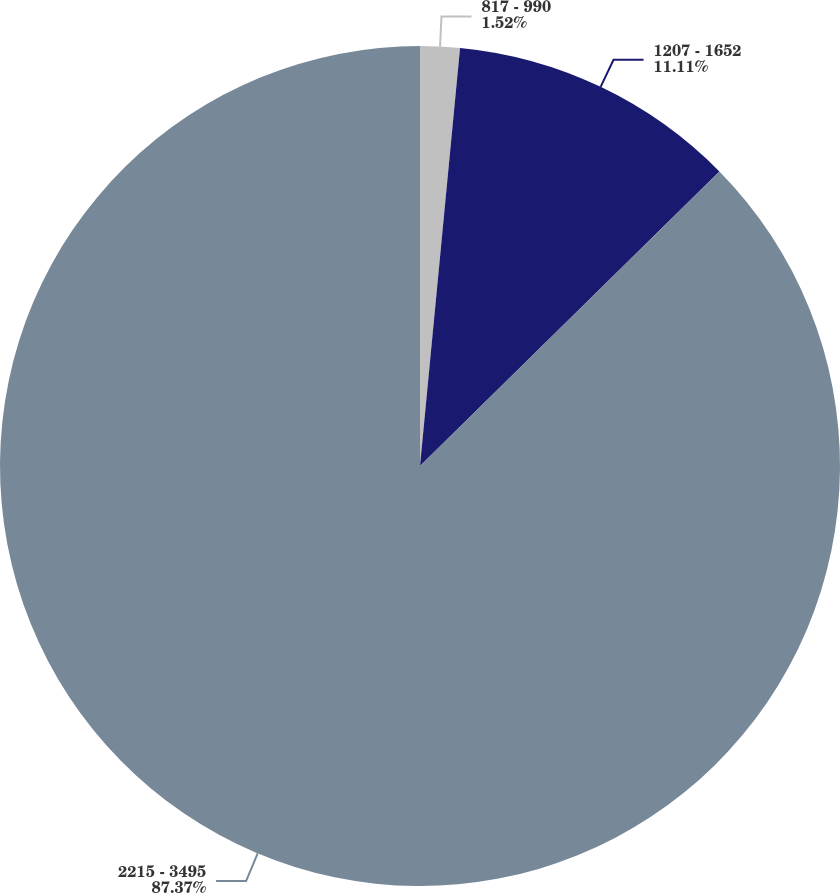Convert chart. <chart><loc_0><loc_0><loc_500><loc_500><pie_chart><fcel>817 - 990<fcel>1207 - 1652<fcel>2215 - 3495<nl><fcel>1.52%<fcel>11.11%<fcel>87.37%<nl></chart> 